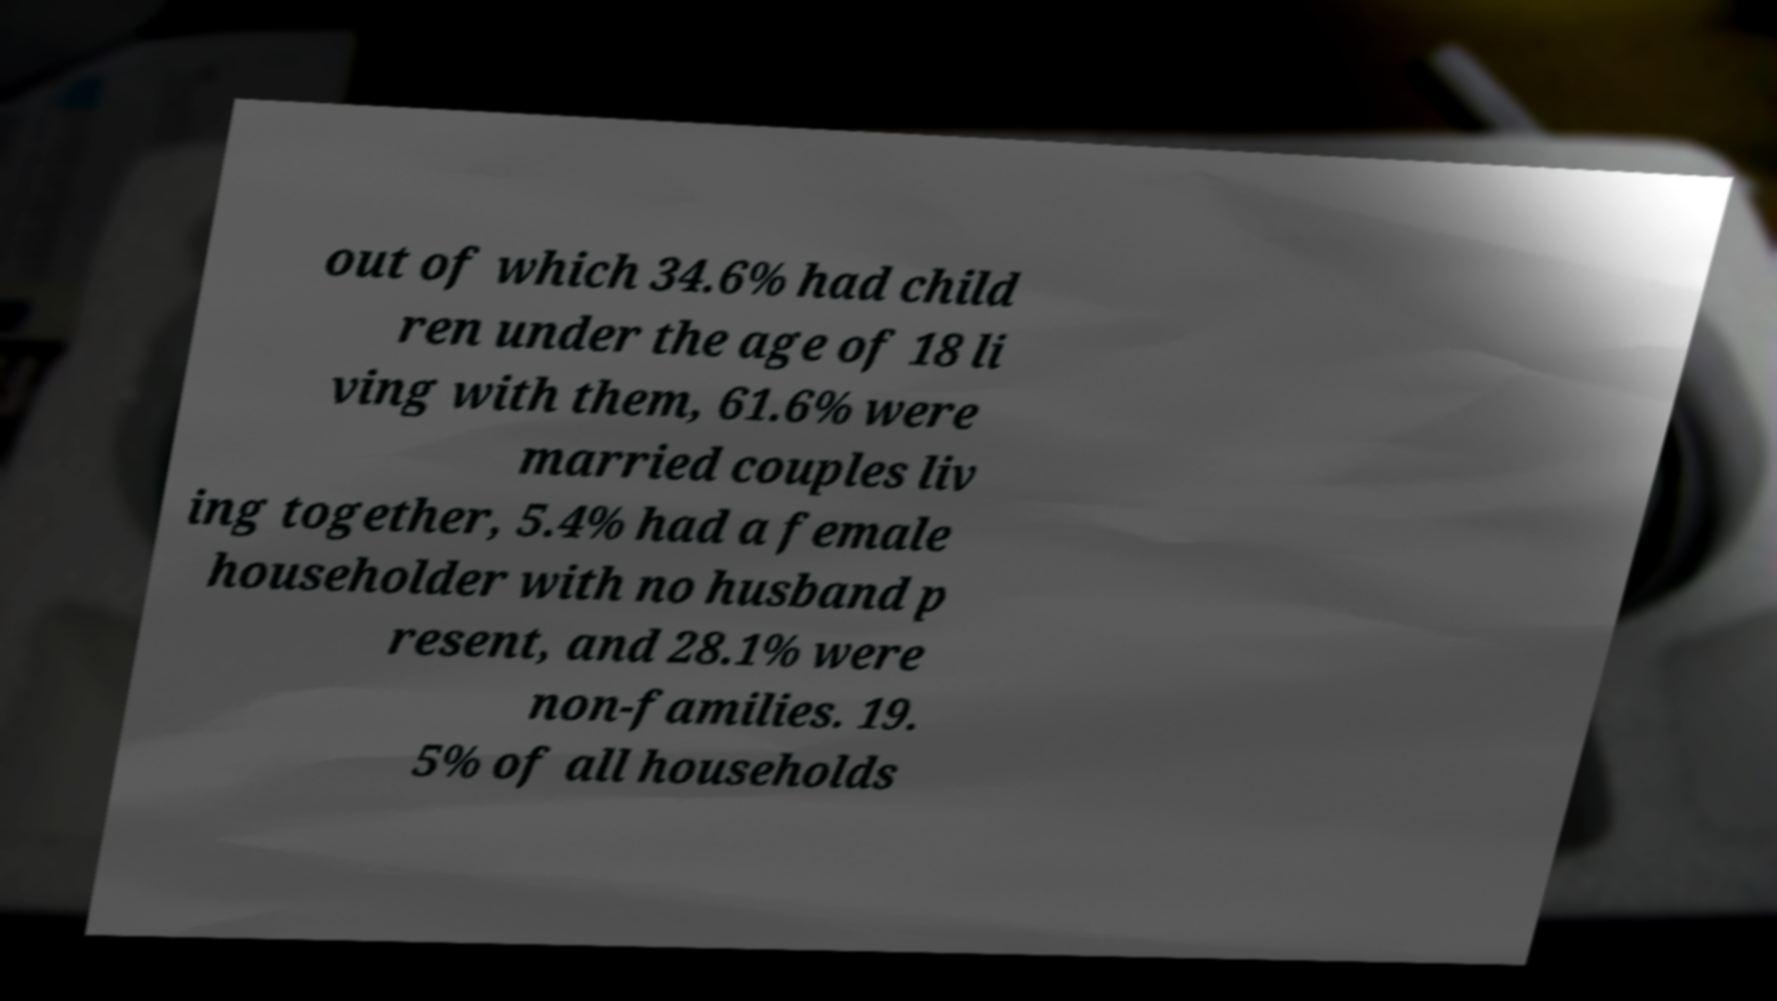For documentation purposes, I need the text within this image transcribed. Could you provide that? out of which 34.6% had child ren under the age of 18 li ving with them, 61.6% were married couples liv ing together, 5.4% had a female householder with no husband p resent, and 28.1% were non-families. 19. 5% of all households 